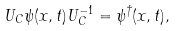<formula> <loc_0><loc_0><loc_500><loc_500>U _ { C } \psi ( x , t ) U _ { C } ^ { - 1 } = \psi ^ { \dagger } ( x , t ) ,</formula> 